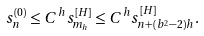Convert formula to latex. <formula><loc_0><loc_0><loc_500><loc_500>s _ { n } ^ { ( 0 ) } \leq C ^ { h } s _ { m _ { h } } ^ { [ H ] } \leq C ^ { h } s _ { n + ( b ^ { 2 } - 2 ) h } ^ { [ H ] } .</formula> 